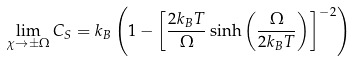Convert formula to latex. <formula><loc_0><loc_0><loc_500><loc_500>\lim _ { \chi \rightarrow \pm \Omega } C _ { S } = k _ { B } \left ( 1 - \left [ \frac { 2 k _ { B } T } { \Omega } \sinh \left ( \frac { \Omega } { 2 k _ { B } T } \right ) \right ] ^ { - 2 } \right )</formula> 